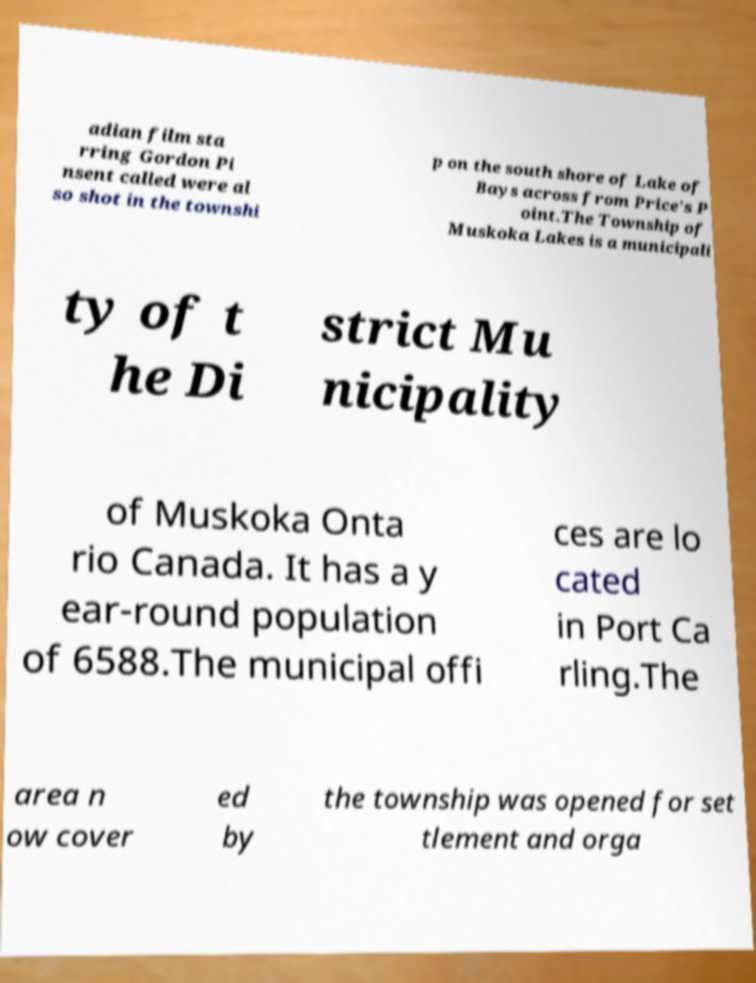Can you read and provide the text displayed in the image?This photo seems to have some interesting text. Can you extract and type it out for me? adian film sta rring Gordon Pi nsent called were al so shot in the townshi p on the south shore of Lake of Bays across from Price's P oint.The Township of Muskoka Lakes is a municipali ty of t he Di strict Mu nicipality of Muskoka Onta rio Canada. It has a y ear-round population of 6588.The municipal offi ces are lo cated in Port Ca rling.The area n ow cover ed by the township was opened for set tlement and orga 